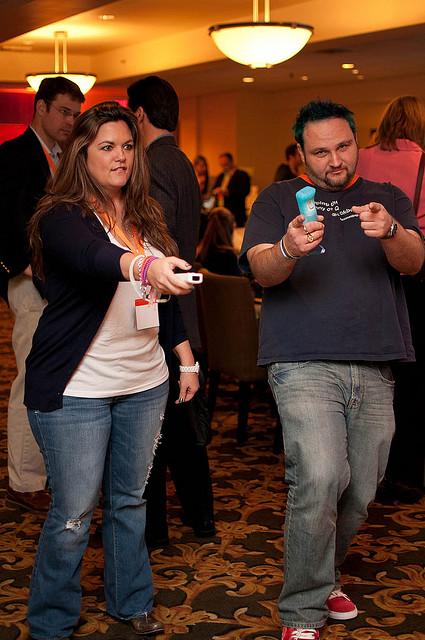Is the man pointing at a person he will hit with the Wiimote?
Quick response, please. No. Does the gentlemen have anything on his wrist?
Write a very short answer. Yes. Are these people playing a game at home?
Short answer required. No. 